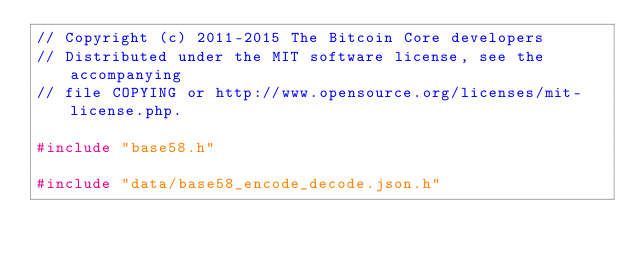<code> <loc_0><loc_0><loc_500><loc_500><_C++_>// Copyright (c) 2011-2015 The Bitcoin Core developers
// Distributed under the MIT software license, see the accompanying
// file COPYING or http://www.opensource.org/licenses/mit-license.php.

#include "base58.h"

#include "data/base58_encode_decode.json.h"</code> 